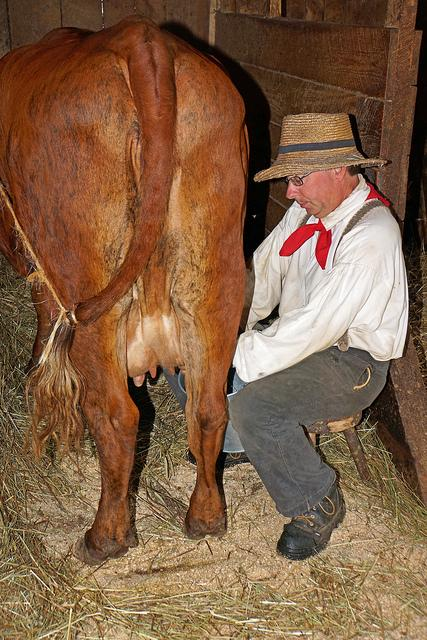What activity is this man involved in? Please explain your reasoning. milking. This man's hand's are oriented towards a cow's udders; he sit's on a short stool and we can see a metal pail below the udders. this set of circumstances is associated from taking milk out of a cow. 